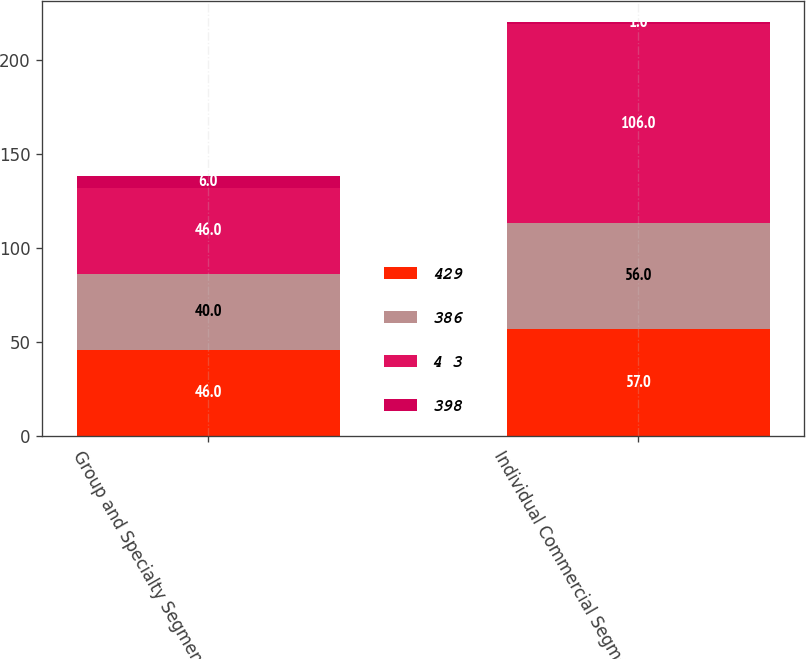<chart> <loc_0><loc_0><loc_500><loc_500><stacked_bar_chart><ecel><fcel>Group and Specialty Segment<fcel>Individual Commercial Segment<nl><fcel>429<fcel>46<fcel>57<nl><fcel>386<fcel>40<fcel>56<nl><fcel>4 3<fcel>46<fcel>106<nl><fcel>398<fcel>6<fcel>1<nl></chart> 